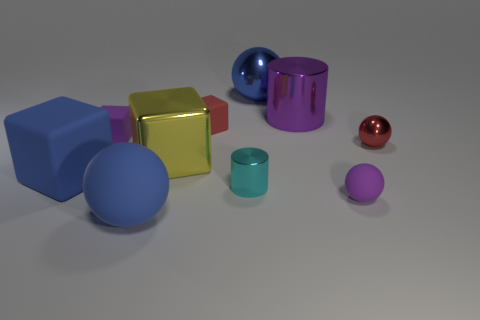How many yellow metallic blocks are there? There is one yellow metallic block in the image, prominently located near the front and slightly to the left, standing out with its bright color and shiny surface. 